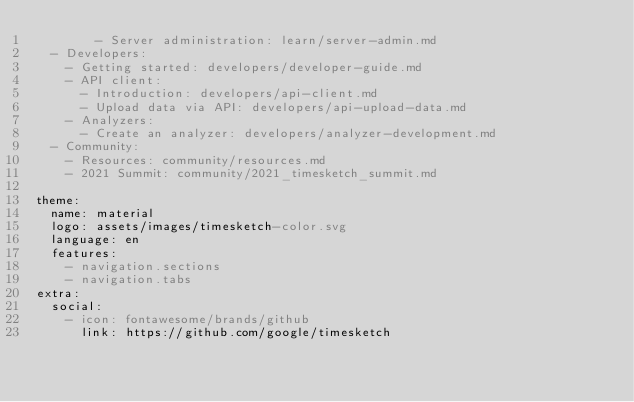<code> <loc_0><loc_0><loc_500><loc_500><_YAML_>        - Server administration: learn/server-admin.md
  - Developers:
    - Getting started: developers/developer-guide.md
    - API client:
      - Introduction: developers/api-client.md
      - Upload data via API: developers/api-upload-data.md
    - Analyzers:
      - Create an analyzer: developers/analyzer-development.md
  - Community:
    - Resources: community/resources.md
    - 2021 Summit: community/2021_timesketch_summit.md
    
theme:
  name: material
  logo: assets/images/timesketch-color.svg 
  language: en
  features:
    - navigation.sections
    - navigation.tabs
extra:
  social:
    - icon: fontawesome/brands/github
      link: https://github.com/google/timesketch</code> 